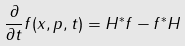<formula> <loc_0><loc_0><loc_500><loc_500>\frac { \partial } { \partial t } f ( x , p , t ) = H ^ { * } f - f ^ { * } H</formula> 